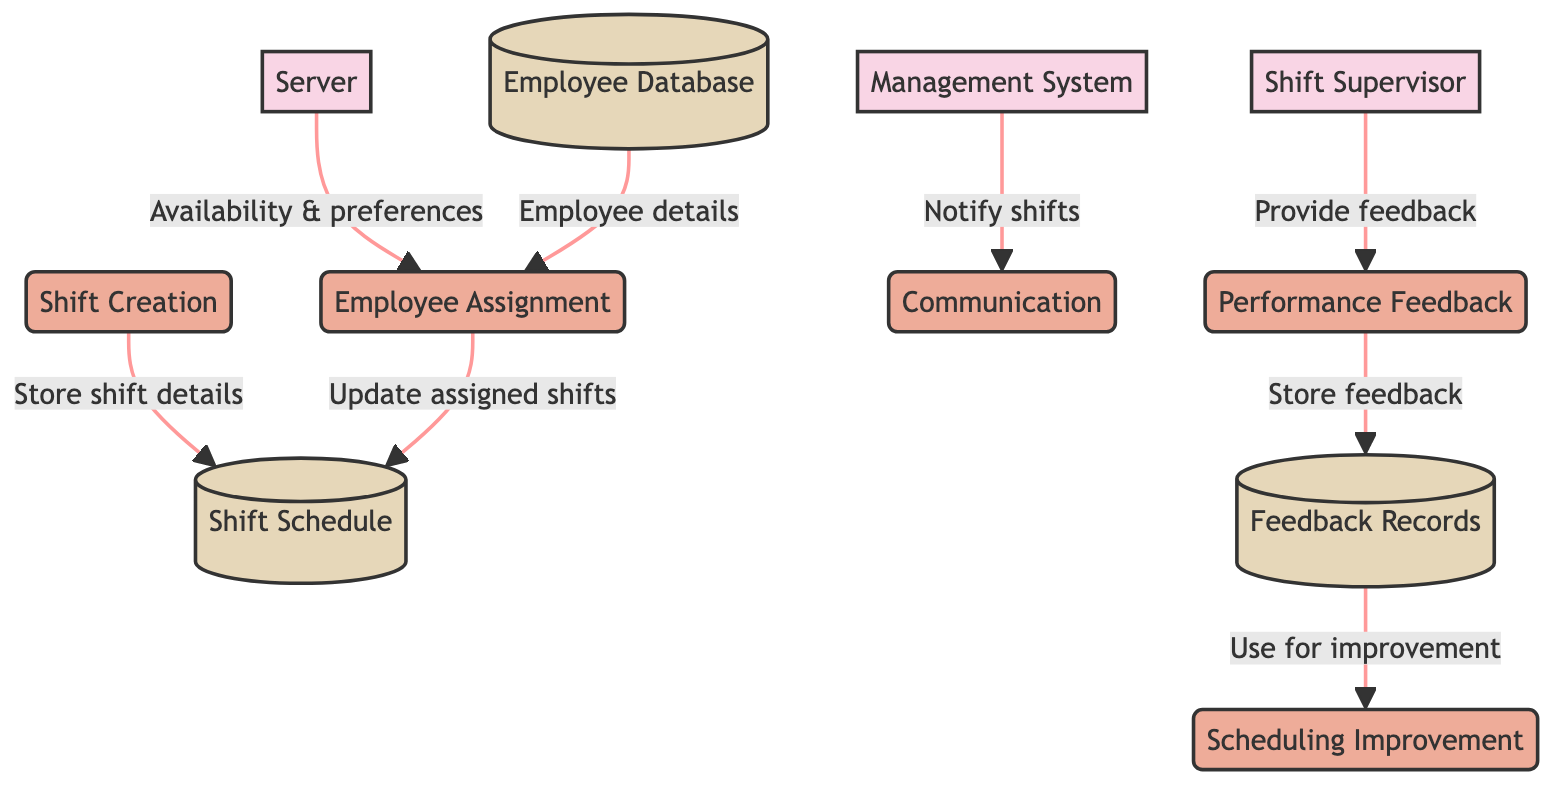What is the main system depicted in the diagram? The diagram's central system is labeled as "Management System", which functions as the hub for handling employee scheduling and shift management processes.
Answer: Management System How many entities are represented in the diagram? The diagram shows three entities: Management System, Server, and Shift Supervisor, indicating the key roles involved in the shift management process.
Answer: Three What process follows "Shift Creation" in the flow? After "Shift Creation", the next process is "Employee Assignment", which involves assigning servers to the newly created shifts.
Answer: Employee Assignment Which data store receives information from both "Shift Creation" and "Employee Assignment"? The "Shift Schedule" data store receives shift details from both the "Shift Creation" and "Employee Assignment" processes, indicating it maintains the records of all shifts.
Answer: Shift Schedule What type of feedback is collected by the "Performance Feedback" process? The "Performance Feedback" process collects feedback specifically on server performance during shifts, which helps in evaluating and improving future scheduling.
Answer: Server performance Which entity provides feedback to the "Performance Feedback" process? The feedback to the "Performance Feedback" process is provided by the "Shift Supervisor", who oversees server performance and gives evaluations on their work.
Answer: Shift Supervisor How is feedback from the "Performance Feedback" process utilized? Feedback collected is stored in the "Feedback Records" data store and is then used in the "Scheduling Improvement" process to refine future shift assignments based on past performance.
Answer: To refine future shift assignments What database contains employee availability and preferences? The "Employee Database" contains essential information about employees, including their availability and preferences for shift assignments.
Answer: Employee Database What is the purpose of the "Communication" process? The "Communication" process serves to notify servers about their assigned shifts, ensuring that they are informed of their schedules through various channels.
Answer: Notify servers about assigned shifts 